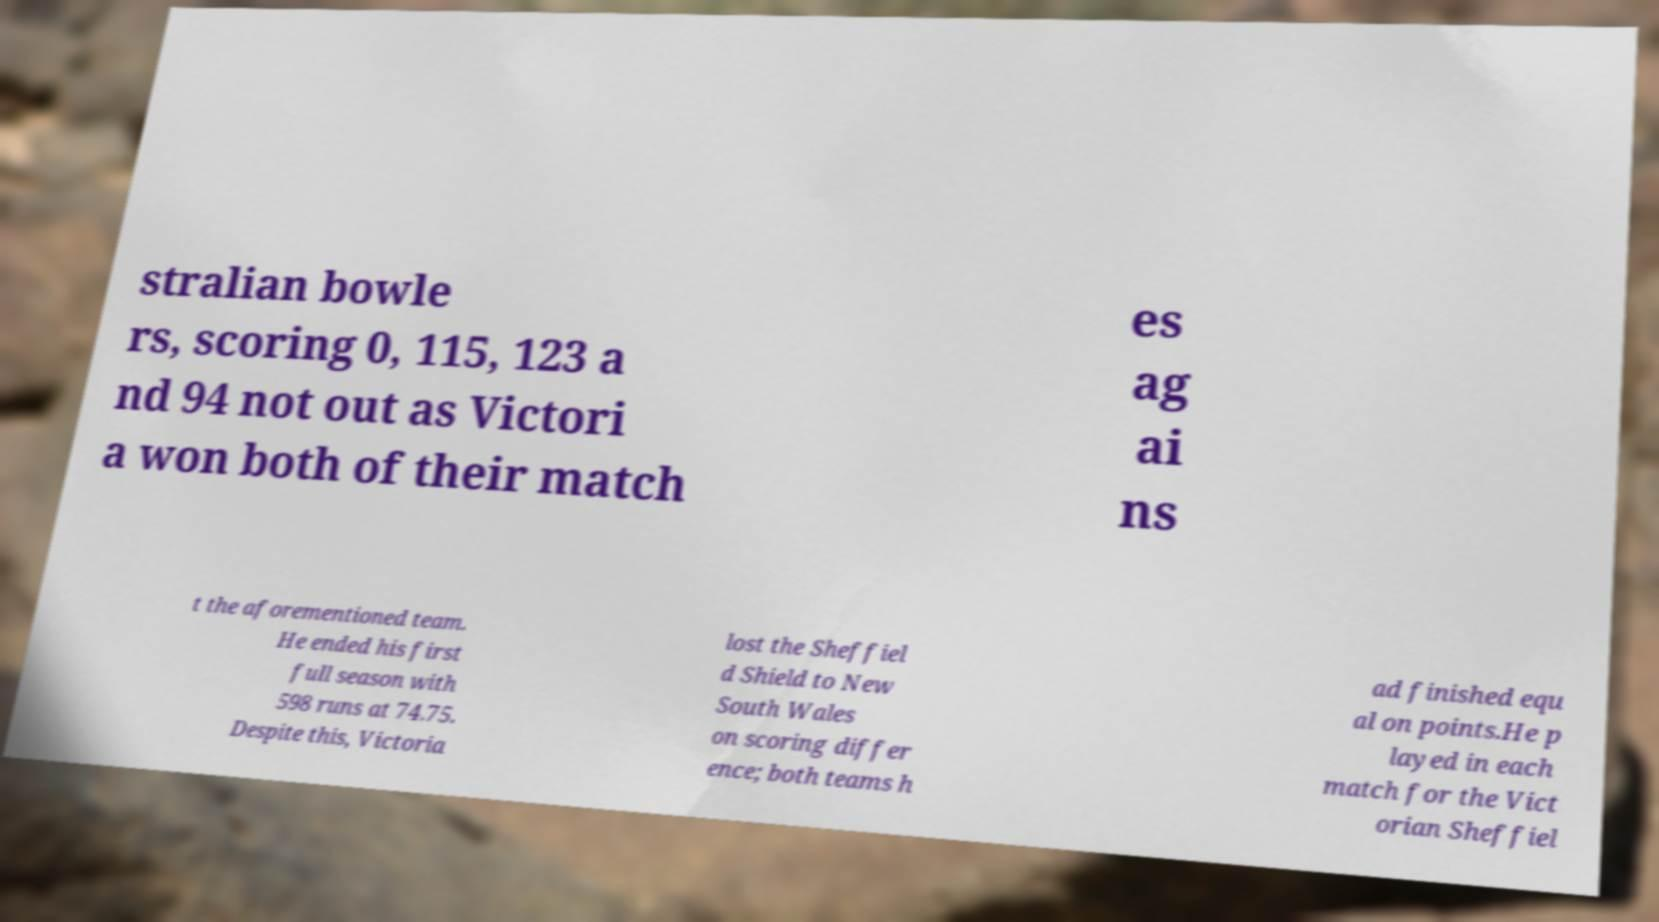I need the written content from this picture converted into text. Can you do that? stralian bowle rs, scoring 0, 115, 123 a nd 94 not out as Victori a won both of their match es ag ai ns t the aforementioned team. He ended his first full season with 598 runs at 74.75. Despite this, Victoria lost the Sheffiel d Shield to New South Wales on scoring differ ence; both teams h ad finished equ al on points.He p layed in each match for the Vict orian Sheffiel 